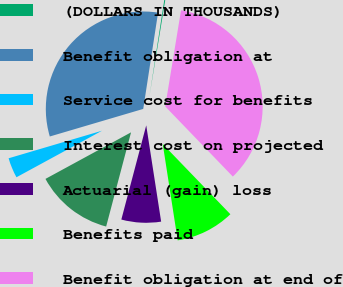Convert chart to OTSL. <chart><loc_0><loc_0><loc_500><loc_500><pie_chart><fcel>(DOLLARS IN THOUSANDS)<fcel>Benefit obligation at<fcel>Service cost for benefits<fcel>Interest cost on projected<fcel>Actuarial (gain) loss<fcel>Benefits paid<fcel>Benefit obligation at end of<nl><fcel>0.16%<fcel>32.0%<fcel>3.36%<fcel>12.96%<fcel>6.56%<fcel>9.76%<fcel>35.2%<nl></chart> 